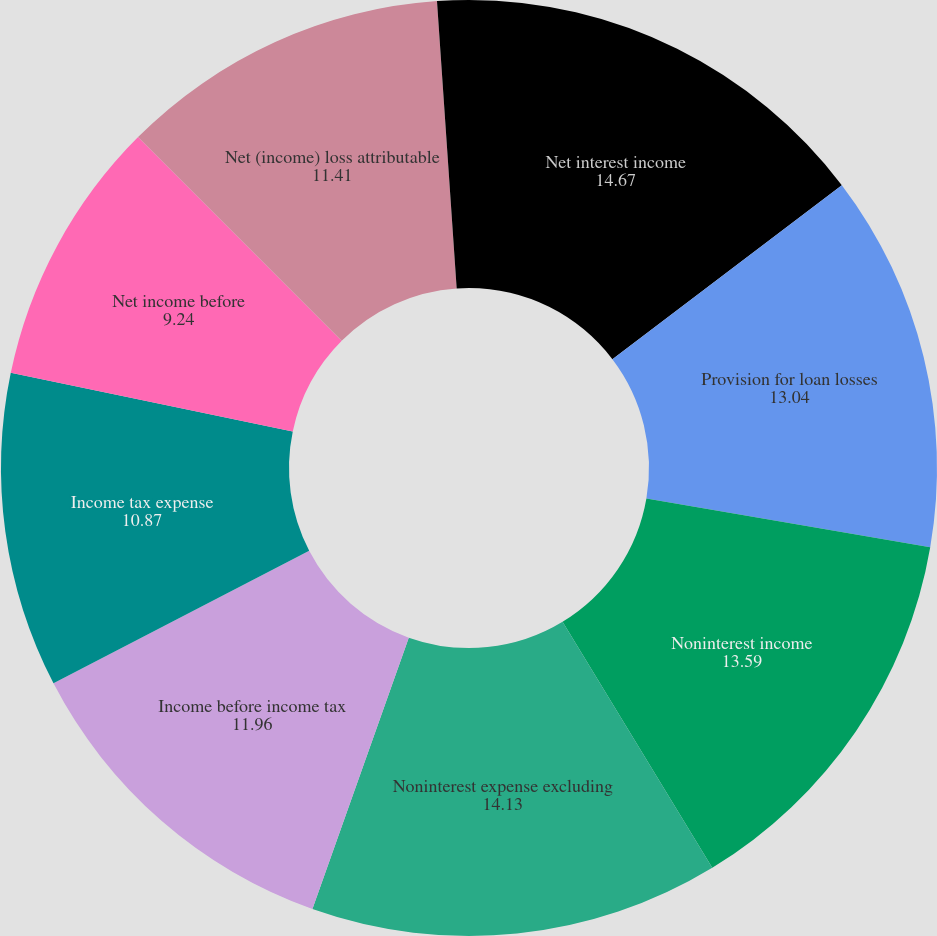Convert chart. <chart><loc_0><loc_0><loc_500><loc_500><pie_chart><fcel>Net interest income<fcel>Provision for loan losses<fcel>Noninterest income<fcel>Noninterest expense excluding<fcel>Income before income tax<fcel>Income tax expense<fcel>Net income before<fcel>Net (income) loss attributable<fcel>Earnings per common<nl><fcel>14.67%<fcel>13.04%<fcel>13.59%<fcel>14.13%<fcel>11.96%<fcel>10.87%<fcel>9.24%<fcel>11.41%<fcel>1.09%<nl></chart> 